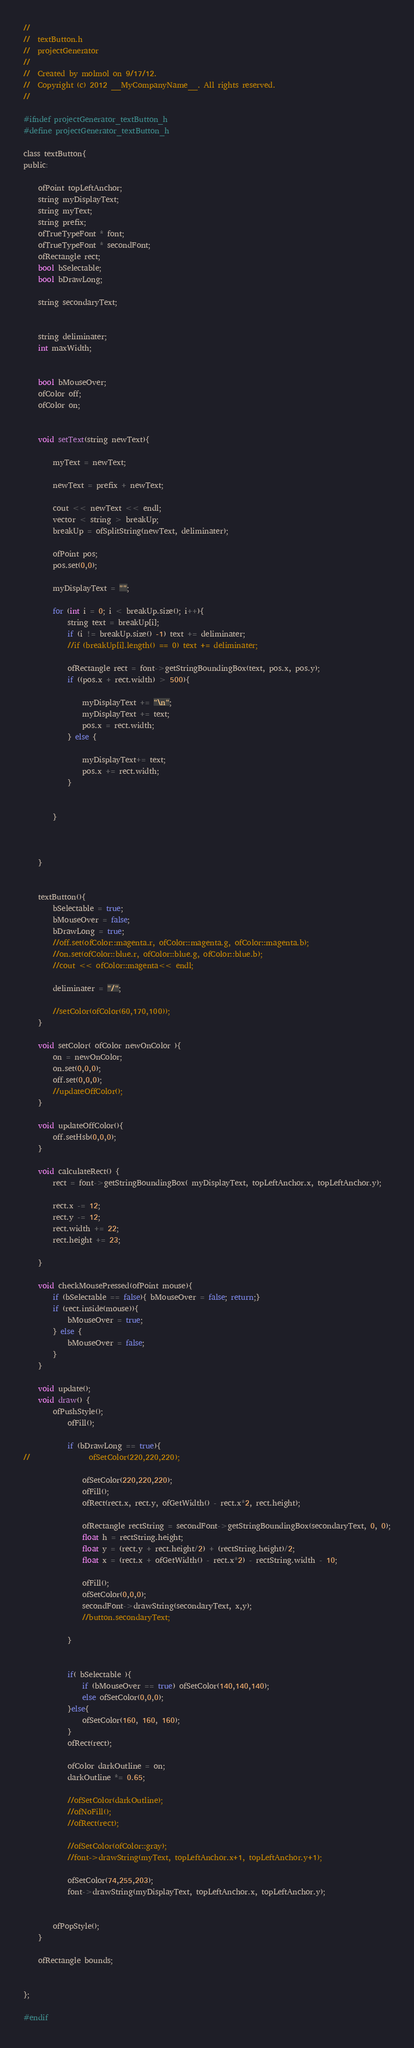Convert code to text. <code><loc_0><loc_0><loc_500><loc_500><_C_>//
//  textButton.h
//  projectGenerator
//
//  Created by molmol on 9/17/12.
//  Copyright (c) 2012 __MyCompanyName__. All rights reserved.
//

#ifndef projectGenerator_textButton_h
#define projectGenerator_textButton_h

class textButton{
public:

    ofPoint topLeftAnchor;
    string myDisplayText;
    string myText;
    string prefix;
    ofTrueTypeFont * font;
    ofTrueTypeFont * secondFont;
    ofRectangle rect;
    bool bSelectable;
    bool bDrawLong;

    string secondaryText;


    string deliminater;
    int maxWidth;


    bool bMouseOver;
    ofColor off;
    ofColor on;


    void setText(string newText){

        myText = newText;

        newText = prefix + newText;

        cout << newText << endl;
        vector < string > breakUp;
        breakUp = ofSplitString(newText, deliminater);

        ofPoint pos;
        pos.set(0,0);

        myDisplayText = "";

        for (int i = 0; i < breakUp.size(); i++){
            string text = breakUp[i];
            if (i != breakUp.size() -1) text += deliminater;
            //if (breakUp[i].length() == 0) text += deliminater;

            ofRectangle rect = font->getStringBoundingBox(text, pos.x, pos.y);
            if ((pos.x + rect.width) > 500){

                myDisplayText += "\n";
                myDisplayText += text;
                pos.x = rect.width;
            } else {

                myDisplayText+= text;
                pos.x += rect.width;
            }


        }



    }


    textButton(){
        bSelectable = true;
        bMouseOver = false;
        bDrawLong = true;
        //off.set(ofColor::magenta.r, ofColor::magenta.g, ofColor::magenta.b);
        //on.set(ofColor::blue.r, ofColor::blue.g, ofColor::blue.b);
        //cout << ofColor::magenta<< endl;

        deliminater = "/";

        //setColor(ofColor(60,170,100));
    }

	void setColor( ofColor newOnColor ){
		on = newOnColor;
        on.set(0,0,0);
        off.set(0,0,0);
		//updateOffColor();
	}

	void updateOffColor(){
        off.setHsb(0,0,0);
	}

    void calculateRect() {
        rect = font->getStringBoundingBox( myDisplayText, topLeftAnchor.x, topLeftAnchor.y);

        rect.x -= 12;
        rect.y -= 12;
        rect.width += 22;
        rect.height += 23;

    }

    void checkMousePressed(ofPoint mouse){
        if (bSelectable == false){ bMouseOver = false; return;}
        if (rect.inside(mouse)){
            bMouseOver = true;
        } else {
            bMouseOver = false;
        }
    }

    void update();
    void draw() {
        ofPushStyle();
			ofFill();

            if (bDrawLong == true){
//                ofSetColor(220,220,220);

                ofSetColor(220,220,220);
                ofFill();
                ofRect(rect.x, rect.y, ofGetWidth() - rect.x*2, rect.height);

                ofRectangle rectString = secondFont->getStringBoundingBox(secondaryText, 0, 0);
                float h = rectString.height;
                float y = (rect.y + rect.height/2) + (rectString.height)/2;
                float x = (rect.x + ofGetWidth() - rect.x*2) - rectString.width - 10;

                ofFill();
                ofSetColor(0,0,0);
                secondFont->drawString(secondaryText, x,y);
                //button.secondaryText;

            }


			if( bSelectable ){
				if (bMouseOver == true) ofSetColor(140,140,140);
				else ofSetColor(0,0,0);
			}else{
				ofSetColor(160, 160, 160);
			}
			ofRect(rect);

			ofColor darkOutline = on;
			darkOutline *= 0.65;

			//ofSetColor(darkOutline);
			//ofNoFill();
			//ofRect(rect);

			//ofSetColor(ofColor::gray);
			//font->drawString(myText, topLeftAnchor.x+1, topLeftAnchor.y+1);

			ofSetColor(74,255,203);
			font->drawString(myDisplayText, topLeftAnchor.x, topLeftAnchor.y);


		ofPopStyle();
    }

    ofRectangle bounds;


};

#endif
</code> 